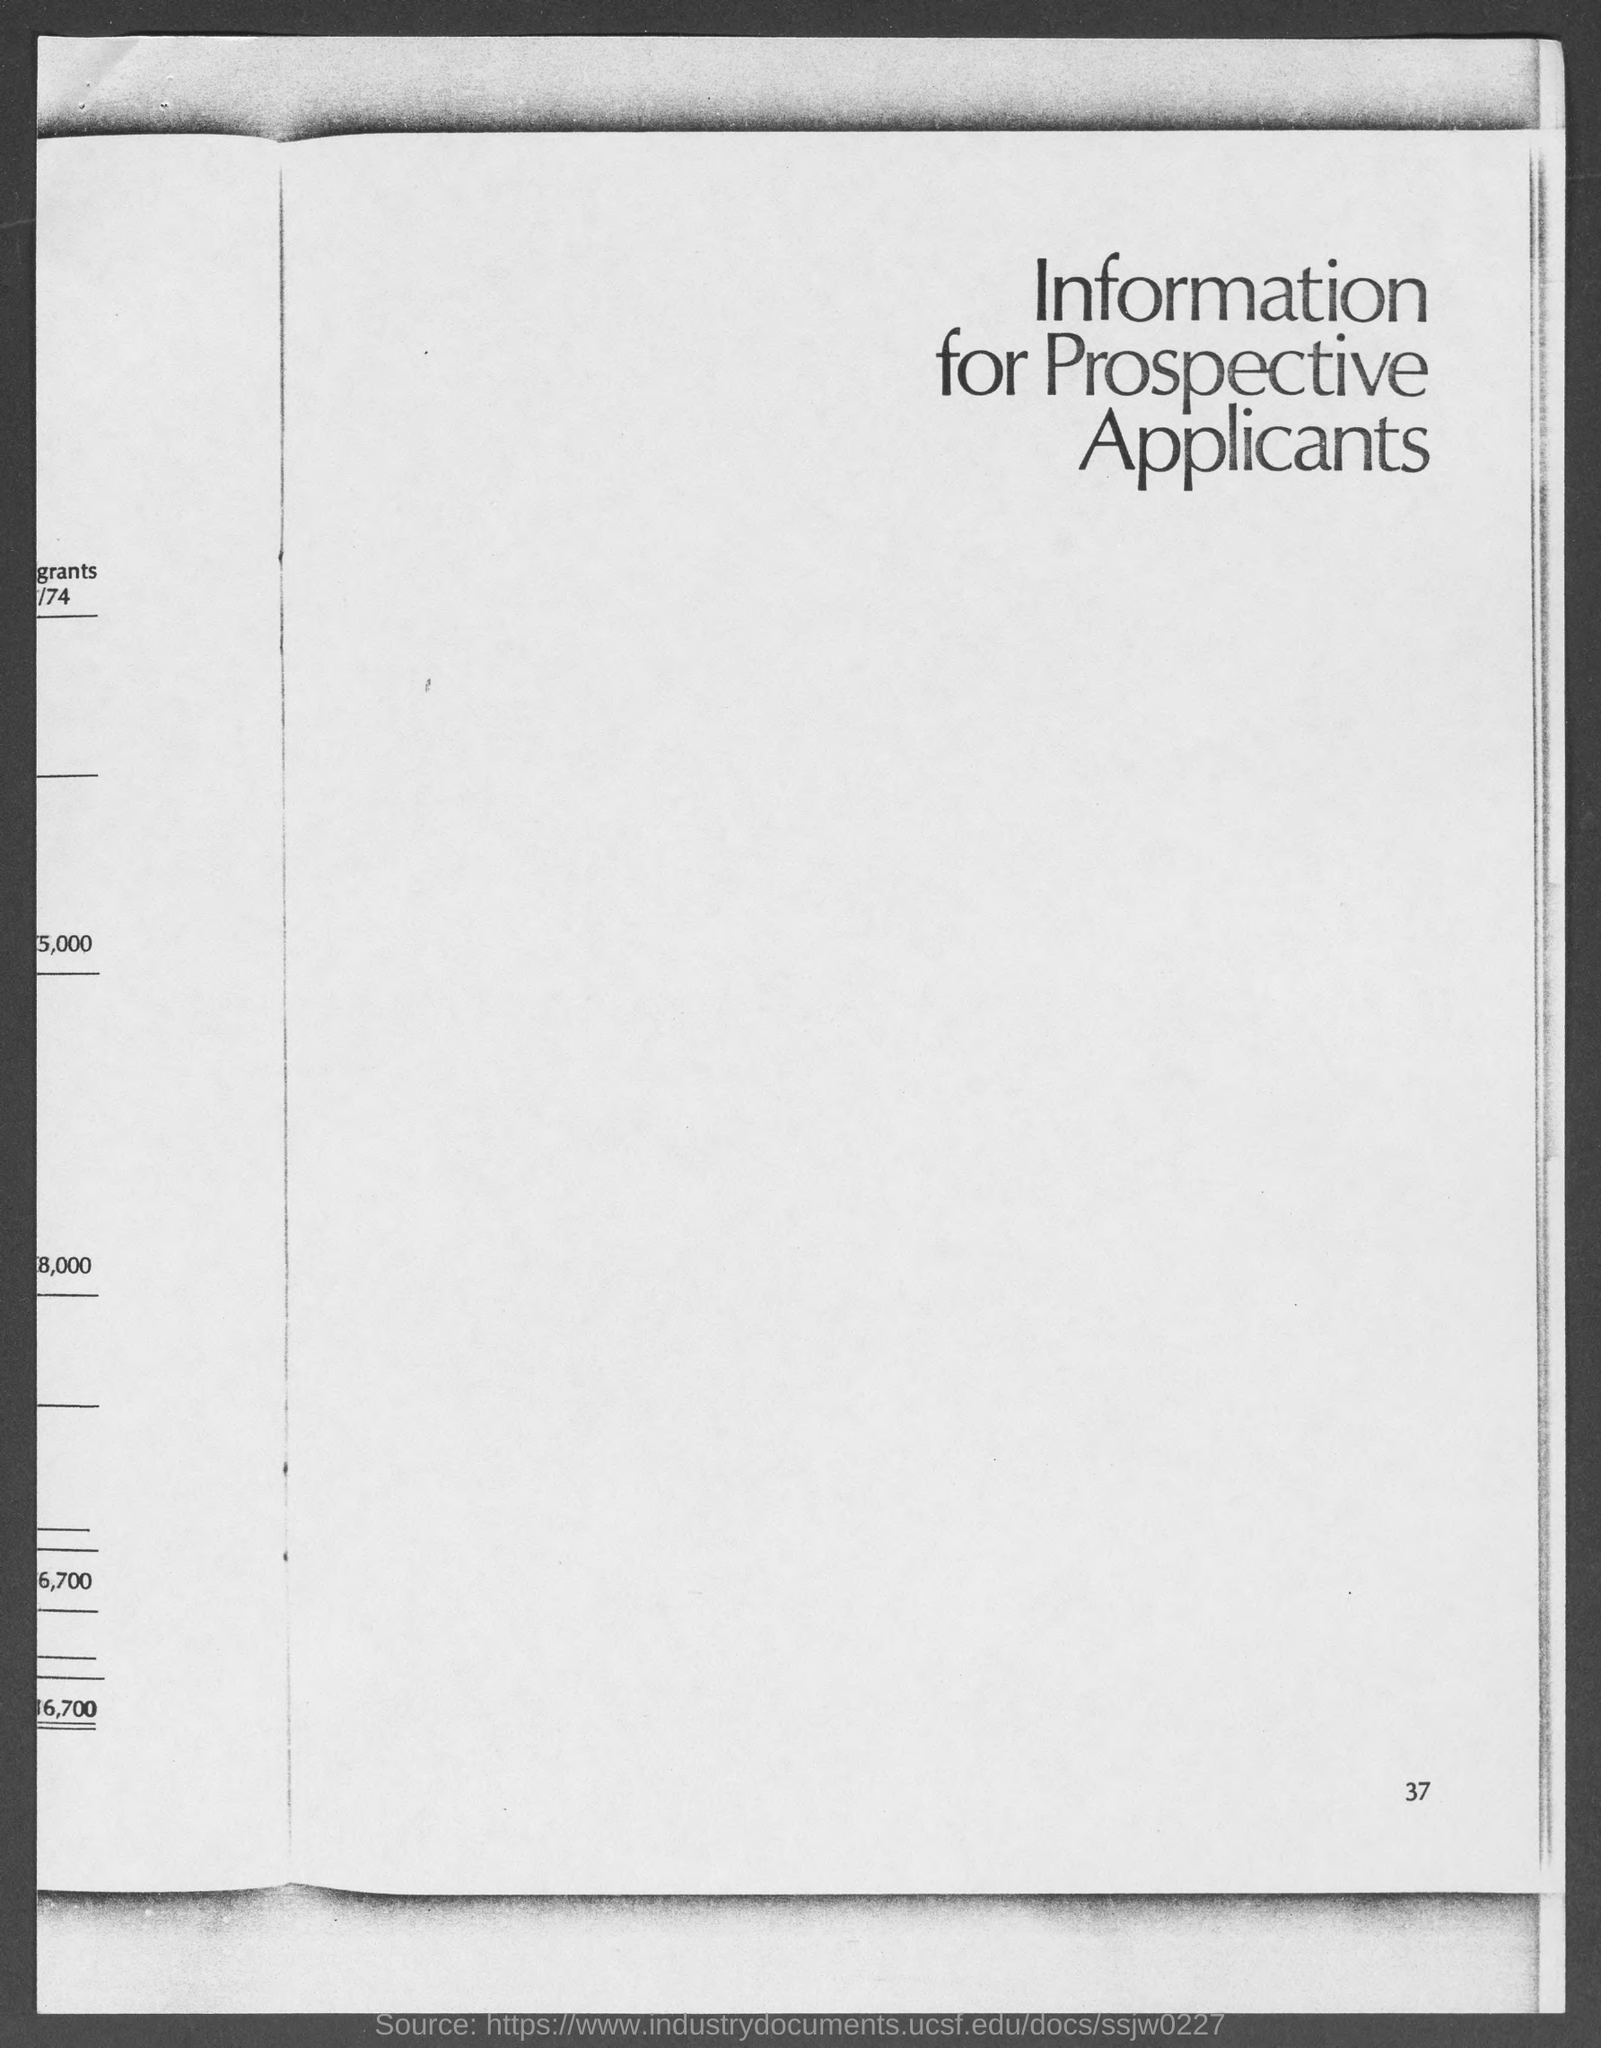What is the page number at bottom of the page?
Your answer should be compact. 37. To whom is the information for ?
Keep it short and to the point. Prospective Applicants. 